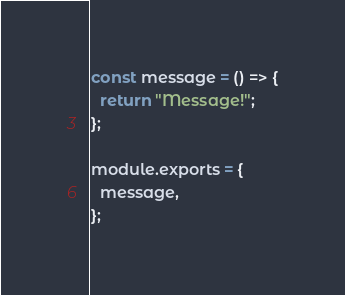<code> <loc_0><loc_0><loc_500><loc_500><_JavaScript_>const message = () => {
  return "Message!";
};

module.exports = {
  message,
};
</code> 